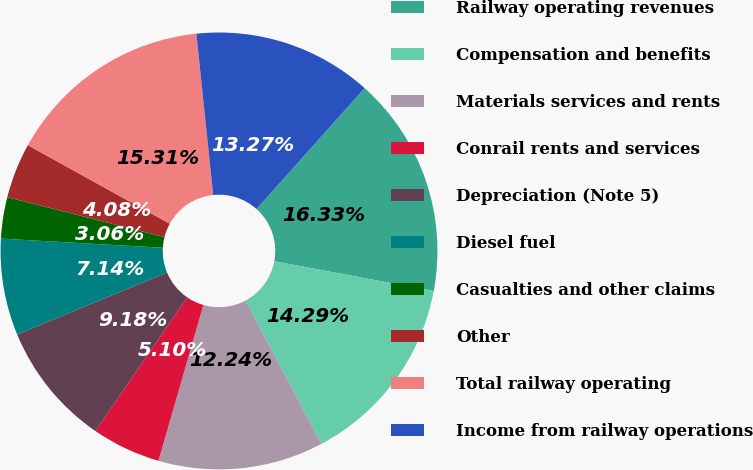Convert chart. <chart><loc_0><loc_0><loc_500><loc_500><pie_chart><fcel>Railway operating revenues<fcel>Compensation and benefits<fcel>Materials services and rents<fcel>Conrail rents and services<fcel>Depreciation (Note 5)<fcel>Diesel fuel<fcel>Casualties and other claims<fcel>Other<fcel>Total railway operating<fcel>Income from railway operations<nl><fcel>16.32%<fcel>14.28%<fcel>12.24%<fcel>5.1%<fcel>9.18%<fcel>7.14%<fcel>3.06%<fcel>4.08%<fcel>15.3%<fcel>13.26%<nl></chart> 